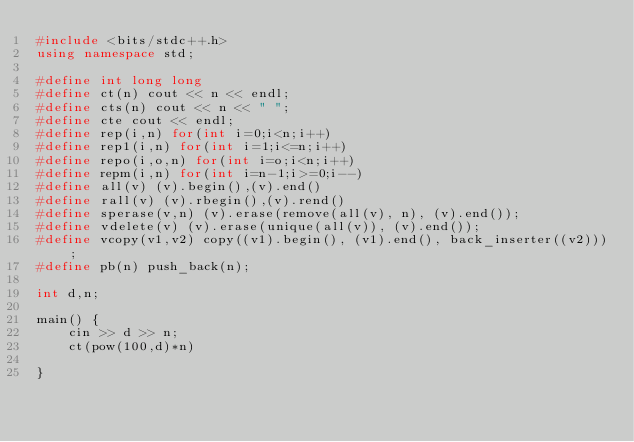Convert code to text. <code><loc_0><loc_0><loc_500><loc_500><_C++_>#include <bits/stdc++.h>
using namespace std;

#define int long long
#define ct(n) cout << n << endl;
#define cts(n) cout << n << " ";
#define cte cout << endl;
#define rep(i,n) for(int i=0;i<n;i++)
#define rep1(i,n) for(int i=1;i<=n;i++)
#define repo(i,o,n) for(int i=o;i<n;i++)
#define repm(i,n) for(int i=n-1;i>=0;i--)
#define all(v) (v).begin(),(v).end()
#define rall(v) (v).rbegin(),(v).rend()
#define sperase(v,n) (v).erase(remove(all(v), n), (v).end());
#define vdelete(v) (v).erase(unique(all(v)), (v).end());
#define vcopy(v1,v2) copy((v1).begin(), (v1).end(), back_inserter((v2)));
#define pb(n) push_back(n);

int d,n;

main() {
    cin >> d >> n;
    ct(pow(100,d)*n)

}



</code> 